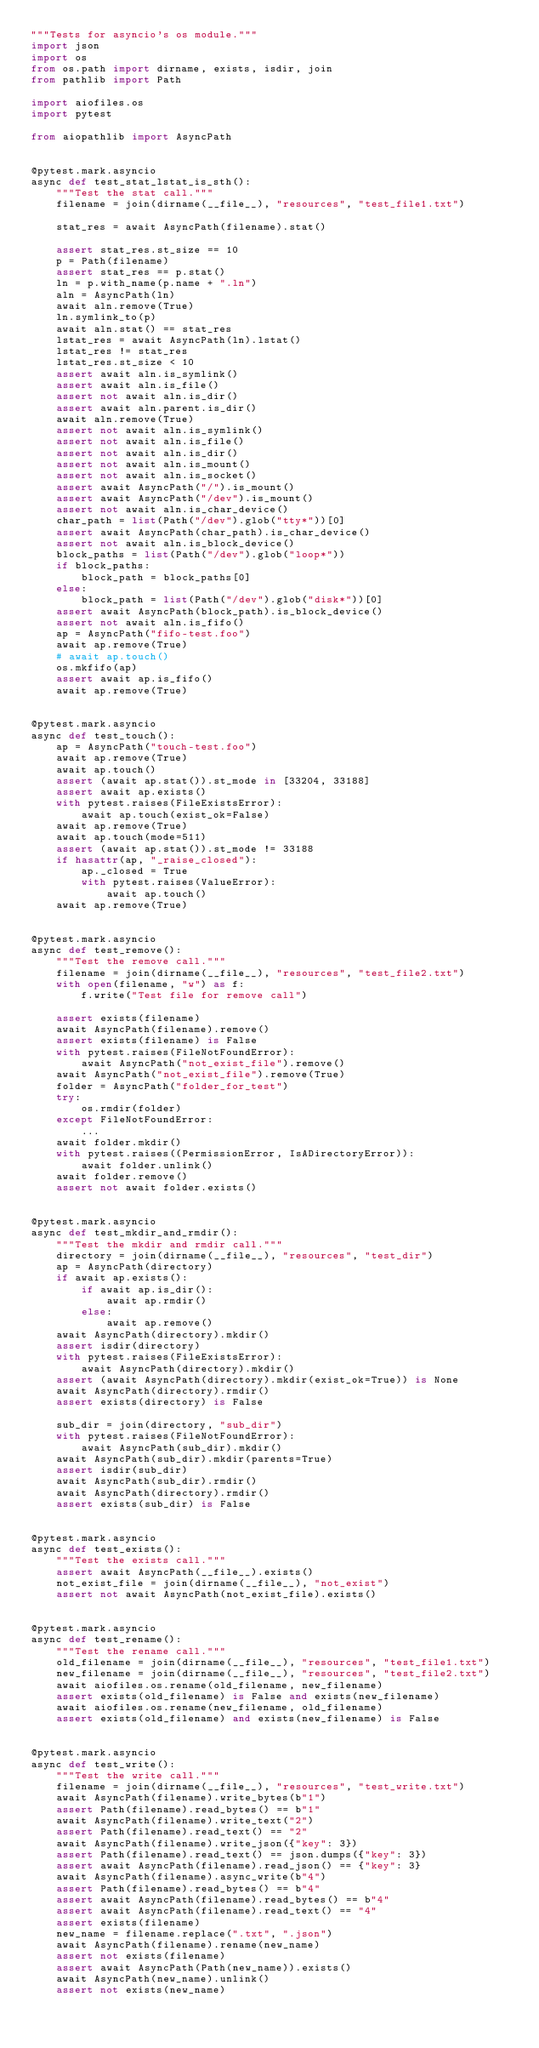Convert code to text. <code><loc_0><loc_0><loc_500><loc_500><_Python_>"""Tests for asyncio's os module."""
import json
import os
from os.path import dirname, exists, isdir, join
from pathlib import Path

import aiofiles.os
import pytest

from aiopathlib import AsyncPath


@pytest.mark.asyncio
async def test_stat_lstat_is_sth():
    """Test the stat call."""
    filename = join(dirname(__file__), "resources", "test_file1.txt")

    stat_res = await AsyncPath(filename).stat()

    assert stat_res.st_size == 10
    p = Path(filename)
    assert stat_res == p.stat()
    ln = p.with_name(p.name + ".ln")
    aln = AsyncPath(ln)
    await aln.remove(True)
    ln.symlink_to(p)
    await aln.stat() == stat_res
    lstat_res = await AsyncPath(ln).lstat()
    lstat_res != stat_res
    lstat_res.st_size < 10
    assert await aln.is_symlink()
    assert await aln.is_file()
    assert not await aln.is_dir()
    assert await aln.parent.is_dir()
    await aln.remove(True)
    assert not await aln.is_symlink()
    assert not await aln.is_file()
    assert not await aln.is_dir()
    assert not await aln.is_mount()
    assert not await aln.is_socket()
    assert await AsyncPath("/").is_mount()
    assert await AsyncPath("/dev").is_mount()
    assert not await aln.is_char_device()
    char_path = list(Path("/dev").glob("tty*"))[0]
    assert await AsyncPath(char_path).is_char_device()
    assert not await aln.is_block_device()
    block_paths = list(Path("/dev").glob("loop*"))
    if block_paths:
        block_path = block_paths[0]
    else:
        block_path = list(Path("/dev").glob("disk*"))[0]
    assert await AsyncPath(block_path).is_block_device()
    assert not await aln.is_fifo()
    ap = AsyncPath("fifo-test.foo")
    await ap.remove(True)
    # await ap.touch()
    os.mkfifo(ap)
    assert await ap.is_fifo()
    await ap.remove(True)


@pytest.mark.asyncio
async def test_touch():
    ap = AsyncPath("touch-test.foo")
    await ap.remove(True)
    await ap.touch()
    assert (await ap.stat()).st_mode in [33204, 33188]
    assert await ap.exists()
    with pytest.raises(FileExistsError):
        await ap.touch(exist_ok=False)
    await ap.remove(True)
    await ap.touch(mode=511)
    assert (await ap.stat()).st_mode != 33188
    if hasattr(ap, "_raise_closed"):
        ap._closed = True
        with pytest.raises(ValueError):
            await ap.touch()
    await ap.remove(True)


@pytest.mark.asyncio
async def test_remove():
    """Test the remove call."""
    filename = join(dirname(__file__), "resources", "test_file2.txt")
    with open(filename, "w") as f:
        f.write("Test file for remove call")

    assert exists(filename)
    await AsyncPath(filename).remove()
    assert exists(filename) is False
    with pytest.raises(FileNotFoundError):
        await AsyncPath("not_exist_file").remove()
    await AsyncPath("not_exist_file").remove(True)
    folder = AsyncPath("folder_for_test")
    try:
        os.rmdir(folder)
    except FileNotFoundError:
        ...
    await folder.mkdir()
    with pytest.raises((PermissionError, IsADirectoryError)):
        await folder.unlink()
    await folder.remove()
    assert not await folder.exists()


@pytest.mark.asyncio
async def test_mkdir_and_rmdir():
    """Test the mkdir and rmdir call."""
    directory = join(dirname(__file__), "resources", "test_dir")
    ap = AsyncPath(directory)
    if await ap.exists():
        if await ap.is_dir():
            await ap.rmdir()
        else:
            await ap.remove()
    await AsyncPath(directory).mkdir()
    assert isdir(directory)
    with pytest.raises(FileExistsError):
        await AsyncPath(directory).mkdir()
    assert (await AsyncPath(directory).mkdir(exist_ok=True)) is None
    await AsyncPath(directory).rmdir()
    assert exists(directory) is False

    sub_dir = join(directory, "sub_dir")
    with pytest.raises(FileNotFoundError):
        await AsyncPath(sub_dir).mkdir()
    await AsyncPath(sub_dir).mkdir(parents=True)
    assert isdir(sub_dir)
    await AsyncPath(sub_dir).rmdir()
    await AsyncPath(directory).rmdir()
    assert exists(sub_dir) is False


@pytest.mark.asyncio
async def test_exists():
    """Test the exists call."""
    assert await AsyncPath(__file__).exists()
    not_exist_file = join(dirname(__file__), "not_exist")
    assert not await AsyncPath(not_exist_file).exists()


@pytest.mark.asyncio
async def test_rename():
    """Test the rename call."""
    old_filename = join(dirname(__file__), "resources", "test_file1.txt")
    new_filename = join(dirname(__file__), "resources", "test_file2.txt")
    await aiofiles.os.rename(old_filename, new_filename)
    assert exists(old_filename) is False and exists(new_filename)
    await aiofiles.os.rename(new_filename, old_filename)
    assert exists(old_filename) and exists(new_filename) is False


@pytest.mark.asyncio
async def test_write():
    """Test the write call."""
    filename = join(dirname(__file__), "resources", "test_write.txt")
    await AsyncPath(filename).write_bytes(b"1")
    assert Path(filename).read_bytes() == b"1"
    await AsyncPath(filename).write_text("2")
    assert Path(filename).read_text() == "2"
    await AsyncPath(filename).write_json({"key": 3})
    assert Path(filename).read_text() == json.dumps({"key": 3})
    assert await AsyncPath(filename).read_json() == {"key": 3}
    await AsyncPath(filename).async_write(b"4")
    assert Path(filename).read_bytes() == b"4"
    assert await AsyncPath(filename).read_bytes() == b"4"
    assert await AsyncPath(filename).read_text() == "4"
    assert exists(filename)
    new_name = filename.replace(".txt", ".json")
    await AsyncPath(filename).rename(new_name)
    assert not exists(filename)
    assert await AsyncPath(Path(new_name)).exists()
    await AsyncPath(new_name).unlink()
    assert not exists(new_name)
</code> 